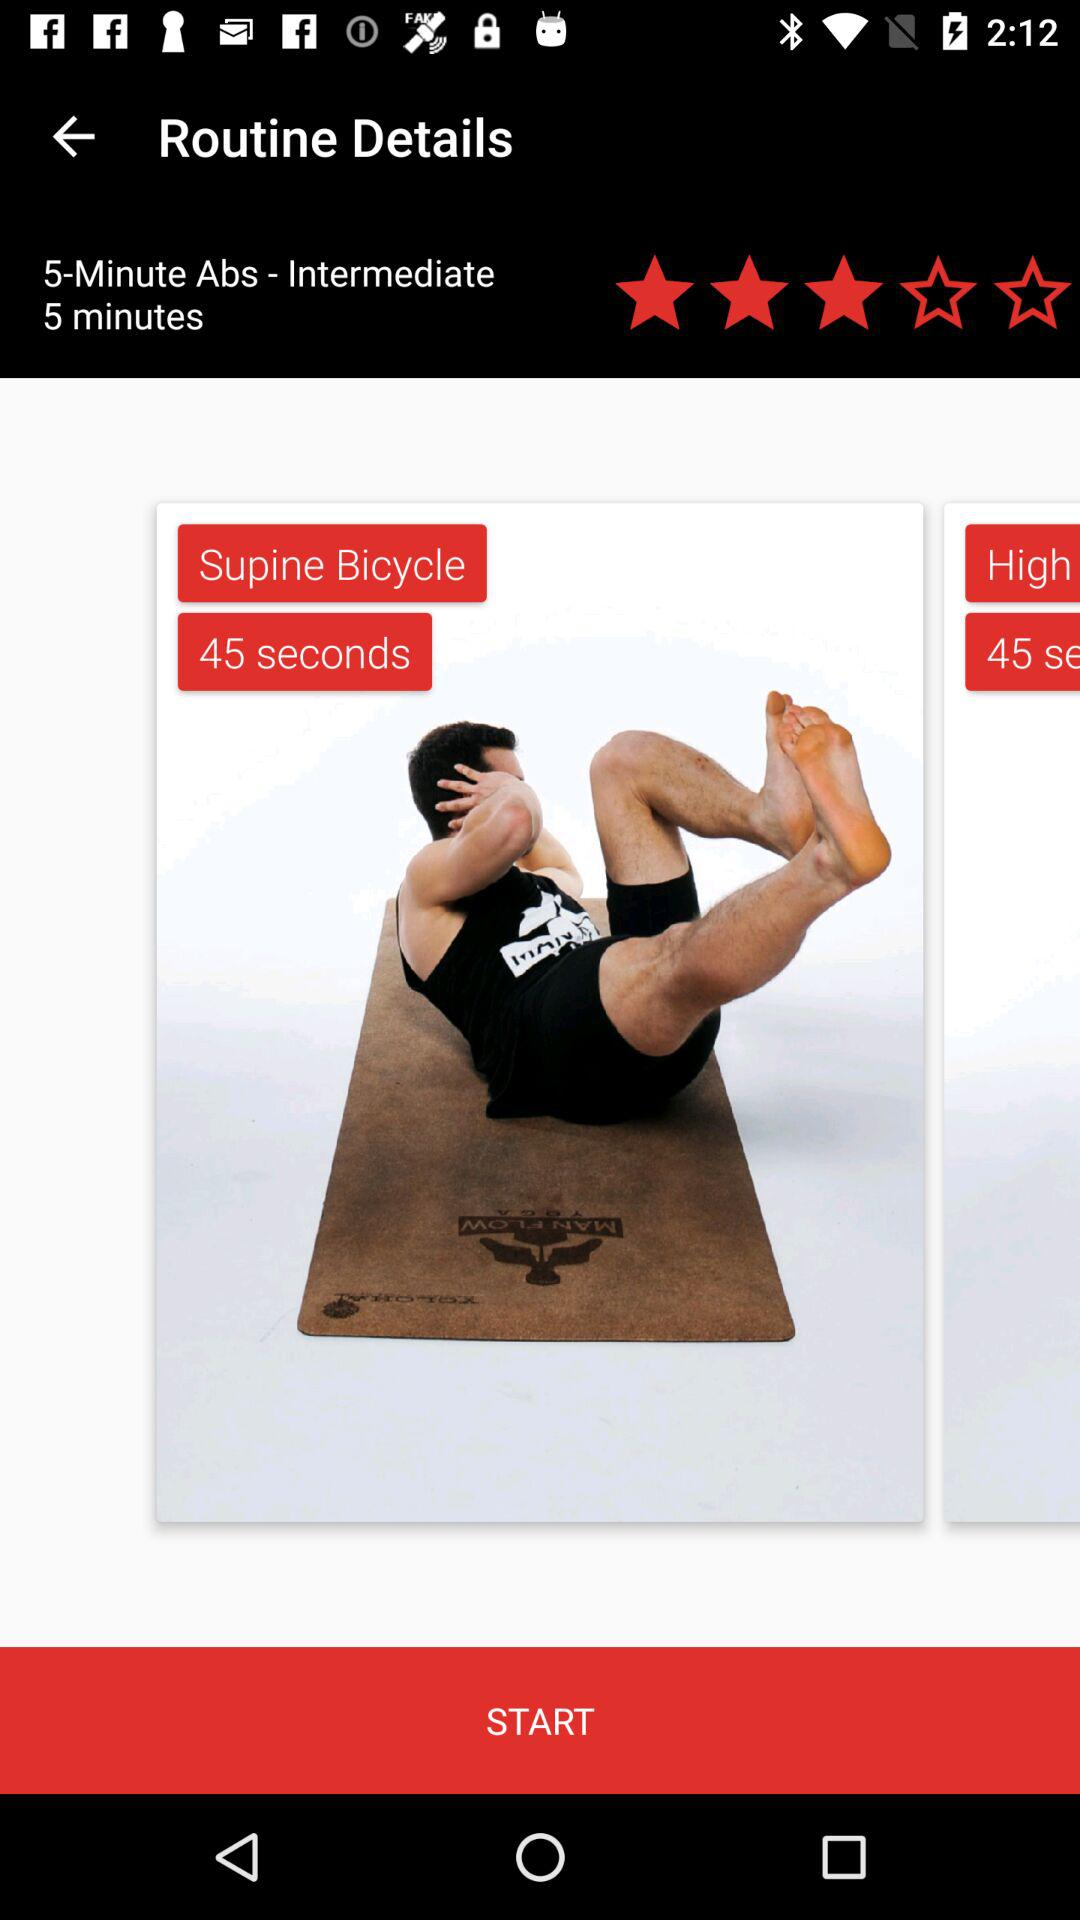How many stars are given to "5-Minute Abs - Intermediate"? There are 3 stars given to "5-Minute Abs - Intermediate". 